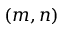Convert formula to latex. <formula><loc_0><loc_0><loc_500><loc_500>( m , n )</formula> 